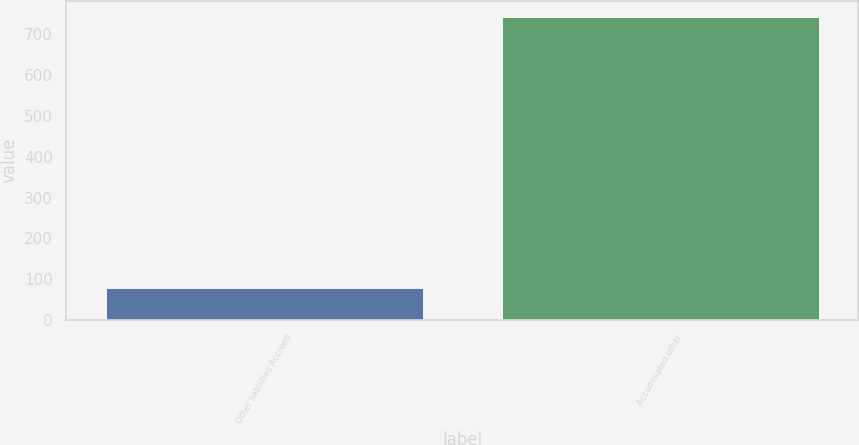Convert chart to OTSL. <chart><loc_0><loc_0><loc_500><loc_500><bar_chart><fcel>Other liabilities Accrued<fcel>Accumulated other<nl><fcel>79<fcel>744<nl></chart> 